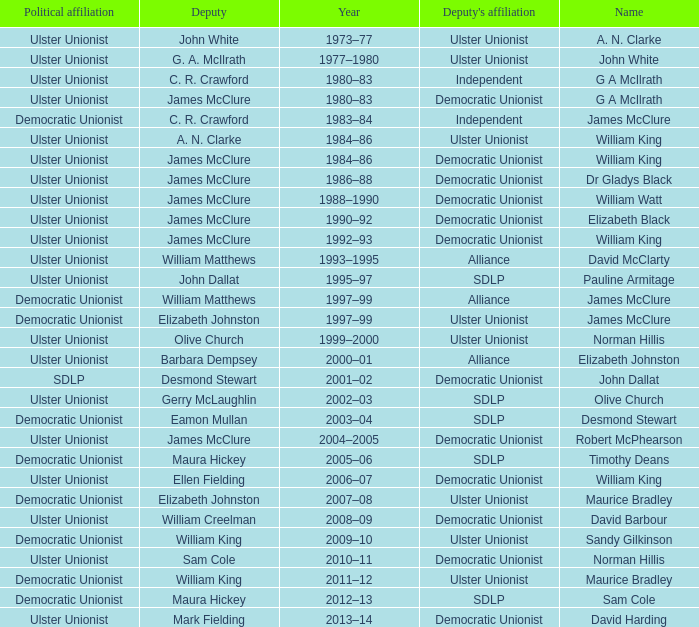What is the name of the deputy in 1992–93? James McClure. 